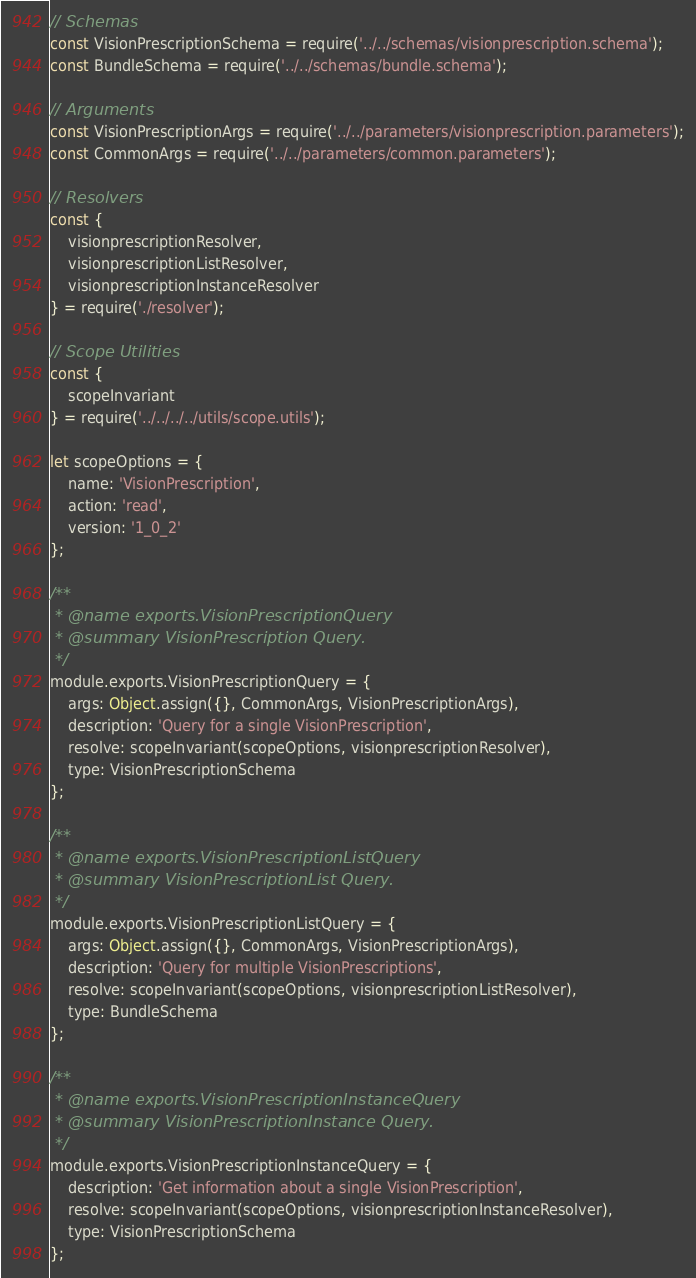<code> <loc_0><loc_0><loc_500><loc_500><_JavaScript_>// Schemas
const VisionPrescriptionSchema = require('../../schemas/visionprescription.schema');
const BundleSchema = require('../../schemas/bundle.schema');

// Arguments
const VisionPrescriptionArgs = require('../../parameters/visionprescription.parameters');
const CommonArgs = require('../../parameters/common.parameters');

// Resolvers
const {
	visionprescriptionResolver,
	visionprescriptionListResolver,
	visionprescriptionInstanceResolver
} = require('./resolver');

// Scope Utilities
const {
	scopeInvariant
} = require('../../../../utils/scope.utils');

let scopeOptions = {
	name: 'VisionPrescription',
	action: 'read',
	version: '1_0_2'
};

/**
 * @name exports.VisionPrescriptionQuery
 * @summary VisionPrescription Query.
 */
module.exports.VisionPrescriptionQuery = {
	args: Object.assign({}, CommonArgs, VisionPrescriptionArgs),
	description: 'Query for a single VisionPrescription',
	resolve: scopeInvariant(scopeOptions, visionprescriptionResolver),
	type: VisionPrescriptionSchema
};

/**
 * @name exports.VisionPrescriptionListQuery
 * @summary VisionPrescriptionList Query.
 */
module.exports.VisionPrescriptionListQuery = {
	args: Object.assign({}, CommonArgs, VisionPrescriptionArgs),
	description: 'Query for multiple VisionPrescriptions',
	resolve: scopeInvariant(scopeOptions, visionprescriptionListResolver),
	type: BundleSchema
};

/**
 * @name exports.VisionPrescriptionInstanceQuery
 * @summary VisionPrescriptionInstance Query.
 */
module.exports.VisionPrescriptionInstanceQuery = {
	description: 'Get information about a single VisionPrescription',
	resolve: scopeInvariant(scopeOptions, visionprescriptionInstanceResolver),
	type: VisionPrescriptionSchema
};
</code> 